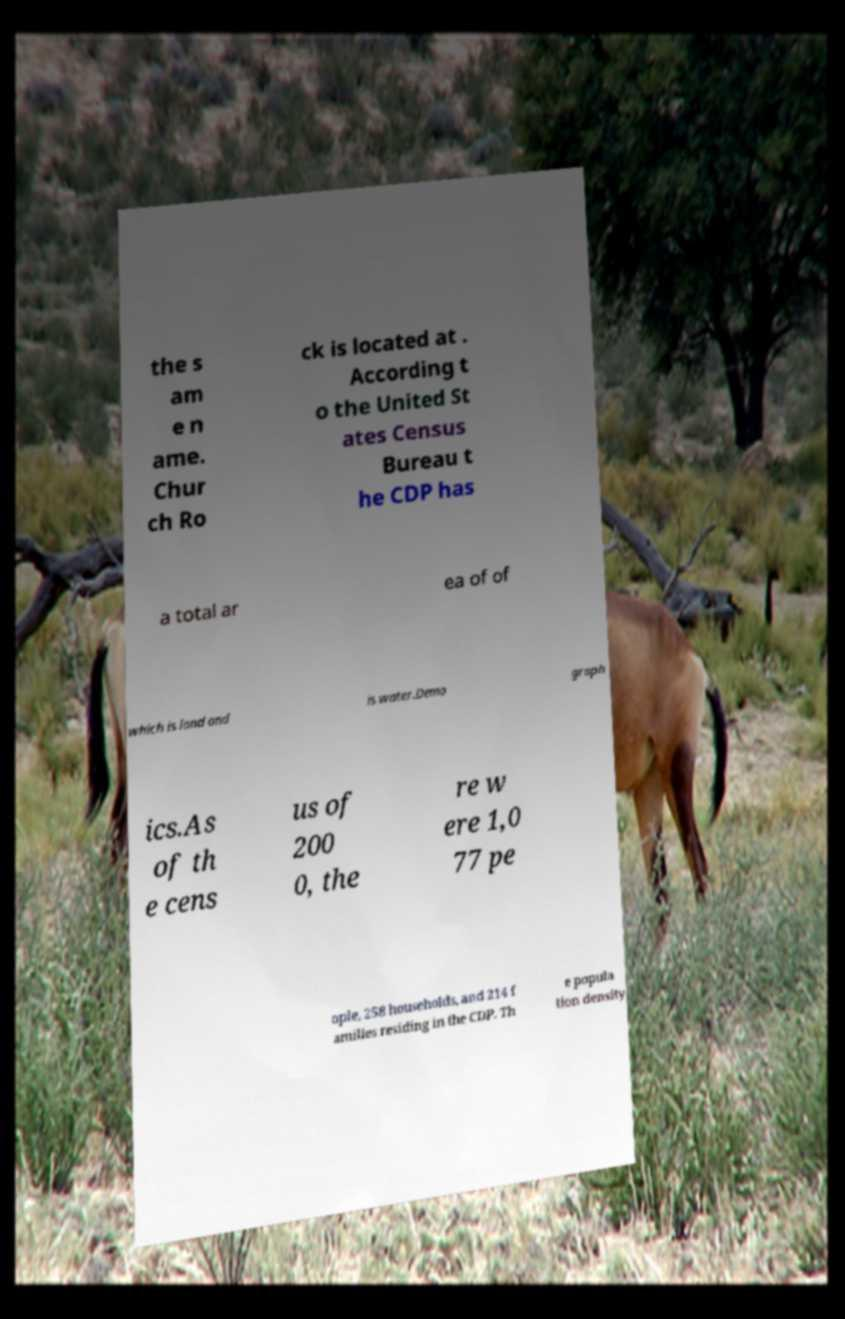Please read and relay the text visible in this image. What does it say? the s am e n ame. Chur ch Ro ck is located at . According t o the United St ates Census Bureau t he CDP has a total ar ea of of which is land and is water.Demo graph ics.As of th e cens us of 200 0, the re w ere 1,0 77 pe ople, 258 households, and 214 f amilies residing in the CDP. Th e popula tion density 